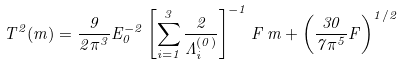Convert formula to latex. <formula><loc_0><loc_0><loc_500><loc_500>T ^ { 2 } ( m ) = \frac { 9 } { 2 \pi ^ { 3 } } E _ { 0 } ^ { - 2 } \left [ \sum _ { i = 1 } ^ { 3 } \frac { 2 } { \Lambda ^ { ( 0 ) } _ { i } } \right ] ^ { - 1 } F \, m + \left ( \frac { 3 0 } { 7 \pi ^ { 5 } } F \right ) ^ { 1 / 2 }</formula> 